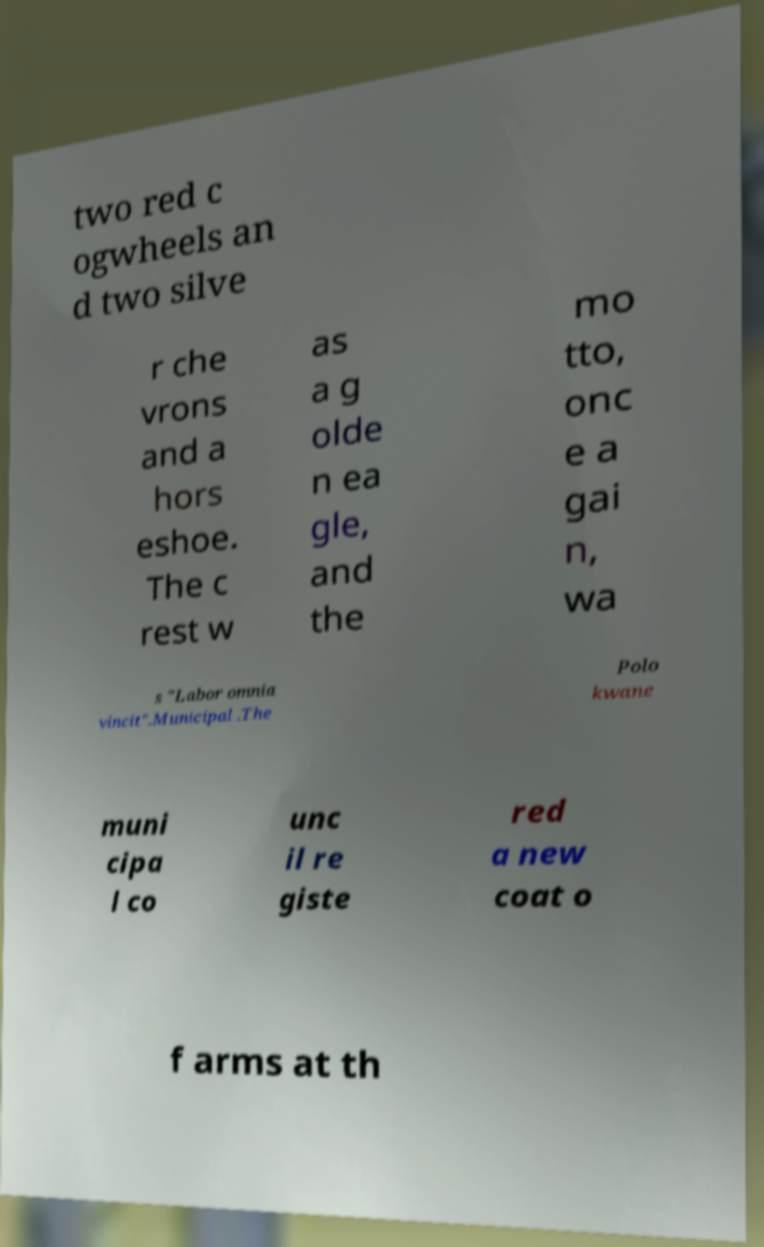What messages or text are displayed in this image? I need them in a readable, typed format. two red c ogwheels an d two silve r che vrons and a hors eshoe. The c rest w as a g olde n ea gle, and the mo tto, onc e a gai n, wa s "Labor omnia vincit".Municipal .The Polo kwane muni cipa l co unc il re giste red a new coat o f arms at th 